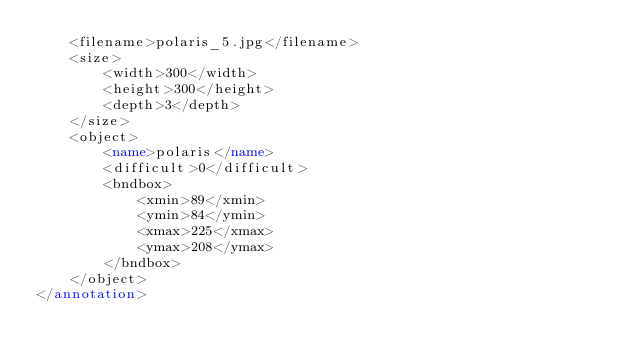Convert code to text. <code><loc_0><loc_0><loc_500><loc_500><_XML_>    <filename>polaris_5.jpg</filename>
    <size>
        <width>300</width>
        <height>300</height>
        <depth>3</depth>
    </size>
    <object>
        <name>polaris</name>
        <difficult>0</difficult>
        <bndbox>
            <xmin>89</xmin>
            <ymin>84</ymin>
            <xmax>225</xmax>
            <ymax>208</ymax>
        </bndbox>
    </object>
</annotation></code> 